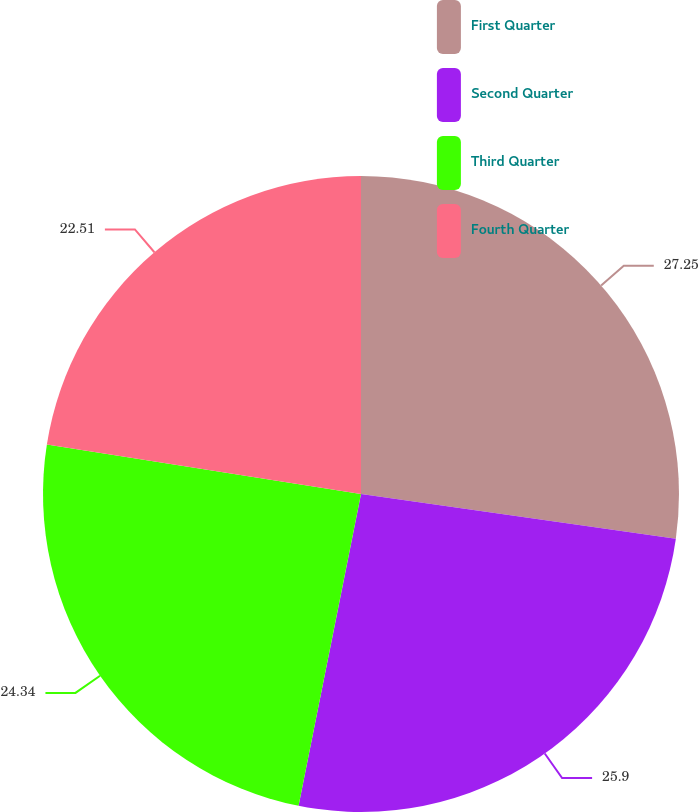Convert chart. <chart><loc_0><loc_0><loc_500><loc_500><pie_chart><fcel>First Quarter<fcel>Second Quarter<fcel>Third Quarter<fcel>Fourth Quarter<nl><fcel>27.24%<fcel>25.9%<fcel>24.34%<fcel>22.51%<nl></chart> 